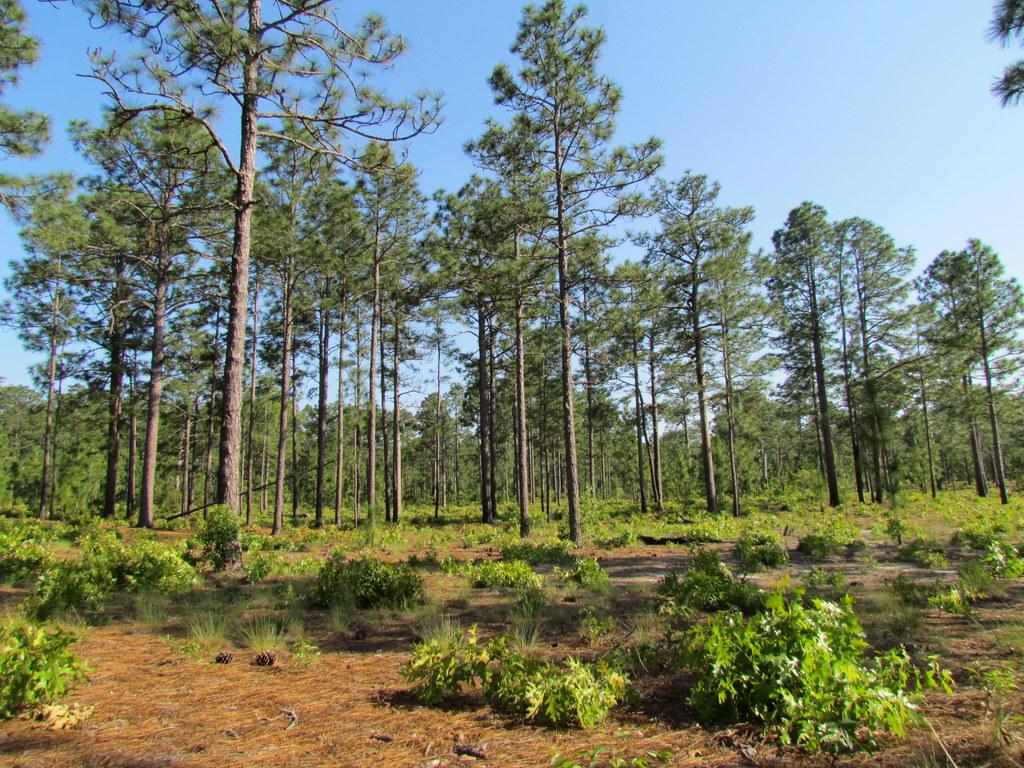What is the primary feature of the image? There are a lot of trees in the image. Are there any other types of vegetation visible in the image? Yes, there are small plants on the ground in the image. How many dimes can be seen scattered among the trees in the image? There are no dimes present in the image; it only features trees and small plants. Can you tell me which person's face is visible in the image? There are no faces visible in the image; it only features trees and small plants. 